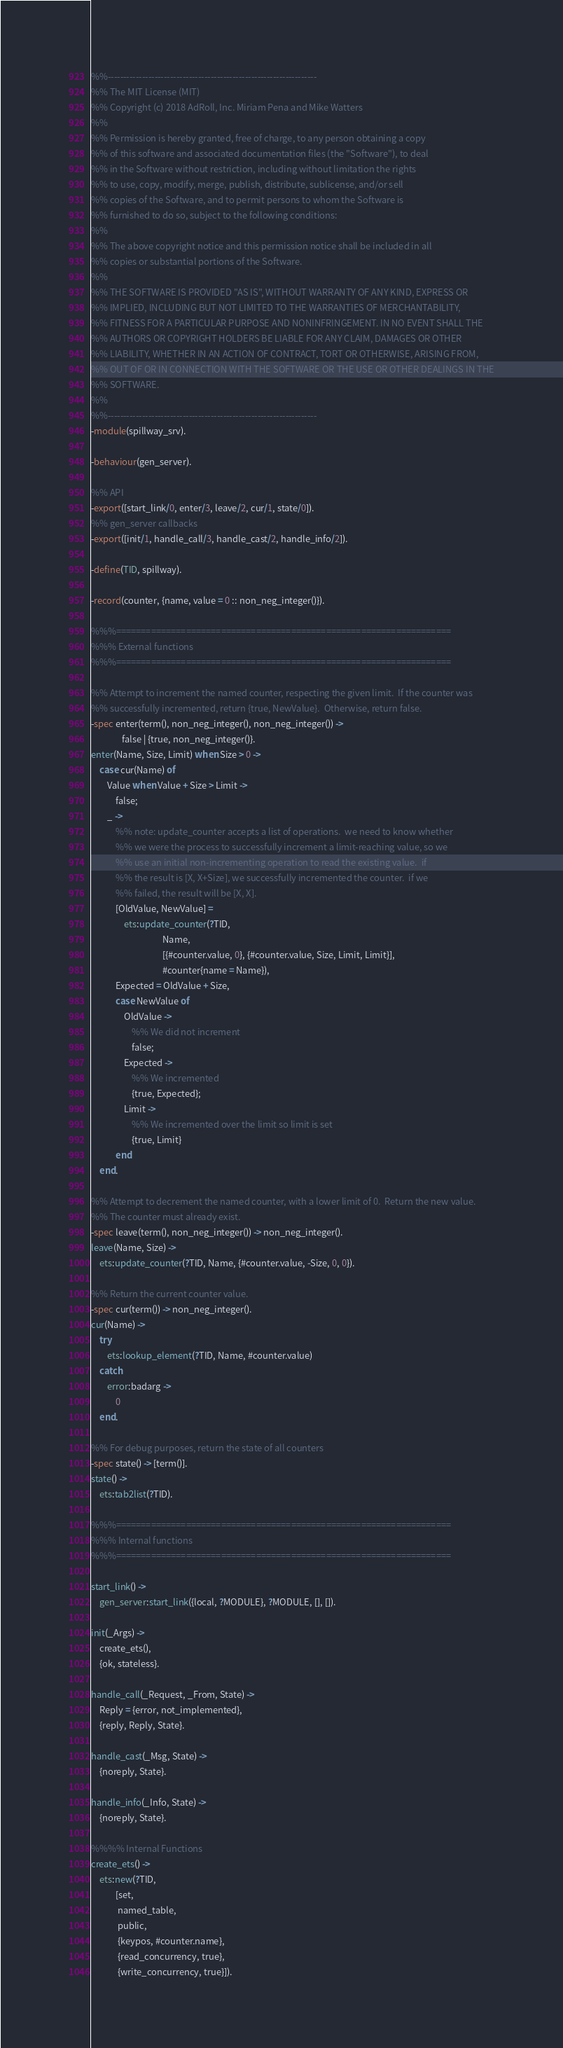Convert code to text. <code><loc_0><loc_0><loc_500><loc_500><_Erlang_>%%-------------------------------------------------------------------
%% The MIT License (MIT)
%% Copyright (c) 2018 AdRoll, Inc. Miriam Pena and Mike Watters
%%
%% Permission is hereby granted, free of charge, to any person obtaining a copy
%% of this software and associated documentation files (the "Software"), to deal
%% in the Software without restriction, including without limitation the rights
%% to use, copy, modify, merge, publish, distribute, sublicense, and/or sell
%% copies of the Software, and to permit persons to whom the Software is
%% furnished to do so, subject to the following conditions:
%%
%% The above copyright notice and this permission notice shall be included in all
%% copies or substantial portions of the Software.
%%
%% THE SOFTWARE IS PROVIDED "AS IS", WITHOUT WARRANTY OF ANY KIND, EXPRESS OR
%% IMPLIED, INCLUDING BUT NOT LIMITED TO THE WARRANTIES OF MERCHANTABILITY,
%% FITNESS FOR A PARTICULAR PURPOSE AND NONINFRINGEMENT. IN NO EVENT SHALL THE
%% AUTHORS OR COPYRIGHT HOLDERS BE LIABLE FOR ANY CLAIM, DAMAGES OR OTHER
%% LIABILITY, WHETHER IN AN ACTION OF CONTRACT, TORT OR OTHERWISE, ARISING FROM,
%% OUT OF OR IN CONNECTION WITH THE SOFTWARE OR THE USE OR OTHER DEALINGS IN THE
%% SOFTWARE.
%%
%%-------------------------------------------------------------------
-module(spillway_srv).

-behaviour(gen_server).

%% API
-export([start_link/0, enter/3, leave/2, cur/1, state/0]).
%% gen_server callbacks
-export([init/1, handle_call/3, handle_cast/2, handle_info/2]).

-define(TID, spillway).

-record(counter, {name, value = 0 :: non_neg_integer()}).

%%%===================================================================
%%% External functions
%%%===================================================================

%% Attempt to increment the named counter, respecting the given limit.  If the counter was
%% successfully incremented, return {true, NewValue}.  Otherwise, return false.
-spec enter(term(), non_neg_integer(), non_neg_integer()) ->
               false | {true, non_neg_integer()}.
enter(Name, Size, Limit) when Size > 0 ->
    case cur(Name) of
        Value when Value + Size > Limit ->
            false;
        _ ->
            %% note: update_counter accepts a list of operations.  we need to know whether
            %% we were the process to successfully increment a limit-reaching value, so we
            %% use an initial non-incrementing operation to read the existing value.  if
            %% the result is [X, X+Size], we successfully incremented the counter.  if we
            %% failed, the result will be [X, X].
            [OldValue, NewValue] =
                ets:update_counter(?TID,
                                   Name,
                                   [{#counter.value, 0}, {#counter.value, Size, Limit, Limit}],
                                   #counter{name = Name}),
            Expected = OldValue + Size,
            case NewValue of
                OldValue ->
                    %% We did not increment
                    false;
                Expected ->
                    %% We incremented
                    {true, Expected};
                Limit ->
                    %% We incremented over the limit so limit is set
                    {true, Limit}
            end
    end.

%% Attempt to decrement the named counter, with a lower limit of 0.  Return the new value.
%% The counter must already exist.
-spec leave(term(), non_neg_integer()) -> non_neg_integer().
leave(Name, Size) ->
    ets:update_counter(?TID, Name, {#counter.value, -Size, 0, 0}).

%% Return the current counter value.
-spec cur(term()) -> non_neg_integer().
cur(Name) ->
    try
        ets:lookup_element(?TID, Name, #counter.value)
    catch
        error:badarg ->
            0
    end.

%% For debug purposes, return the state of all counters
-spec state() -> [term()].
state() ->
    ets:tab2list(?TID).

%%%===================================================================
%%% Internal functions
%%%===================================================================

start_link() ->
    gen_server:start_link({local, ?MODULE}, ?MODULE, [], []).

init(_Args) ->
    create_ets(),
    {ok, stateless}.

handle_call(_Request, _From, State) ->
    Reply = {error, not_implemented},
    {reply, Reply, State}.

handle_cast(_Msg, State) ->
    {noreply, State}.

handle_info(_Info, State) ->
    {noreply, State}.

%%%% Internal Functions
create_ets() ->
    ets:new(?TID,
            [set,
             named_table,
             public,
             {keypos, #counter.name},
             {read_concurrency, true},
             {write_concurrency, true}]).
</code> 